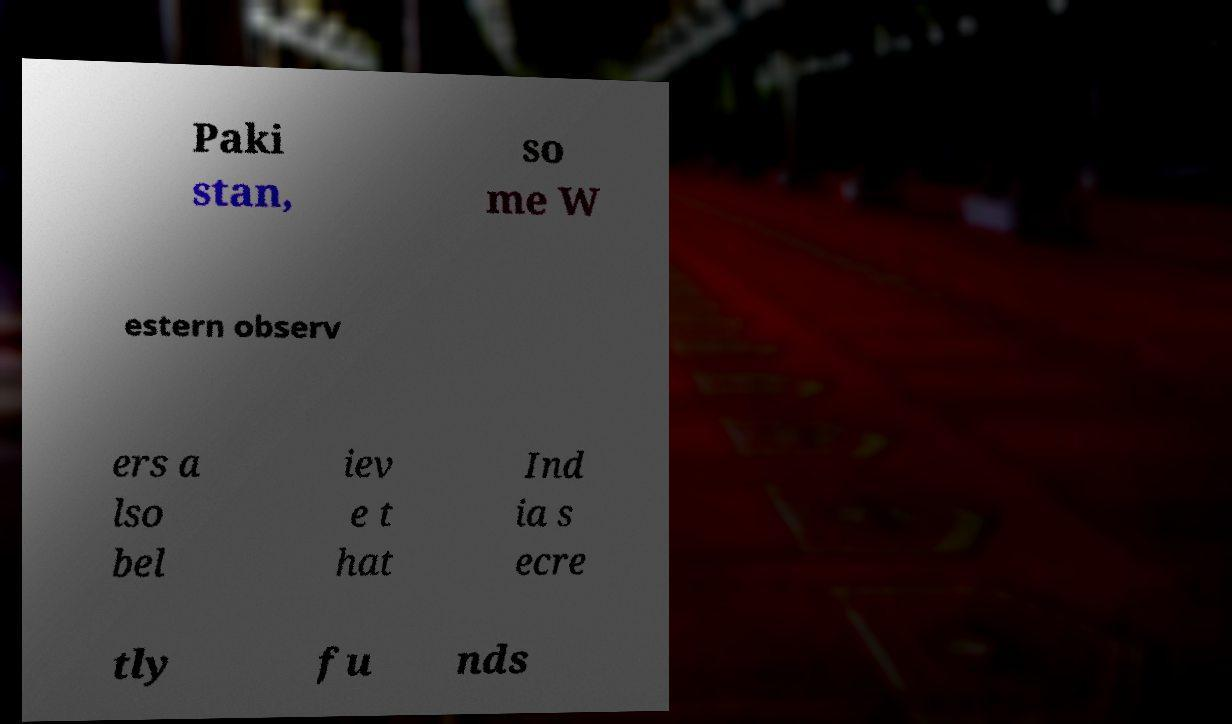Could you extract and type out the text from this image? Paki stan, so me W estern observ ers a lso bel iev e t hat Ind ia s ecre tly fu nds 